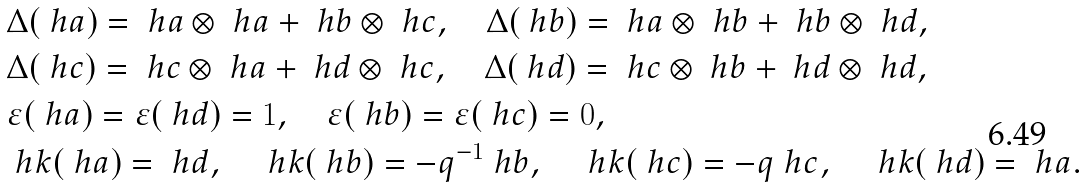<formula> <loc_0><loc_0><loc_500><loc_500>& \Delta ( \ h a ) = \ h a \otimes \ h a + \ h b \otimes \ h c , \quad \Delta ( \ h b ) = \ h a \otimes \ h b + \ h b \otimes \ h d , \\ & \Delta ( \ h c ) = \ h c \otimes \ h a + \ h d \otimes \ h c , \quad \Delta ( \ h d ) = \ h c \otimes \ h b + \ h d \otimes \ h d , \\ & \varepsilon ( \ h a ) = \varepsilon ( \ h d ) = 1 , \quad \varepsilon ( \ h b ) = \varepsilon ( \ h c ) = 0 , \\ & \ h k ( \ h a ) = \ h d , \quad \ h k ( \ h b ) = - q ^ { - 1 } \ h b , \quad \ h k ( \ h c ) = - q \ h c , \quad \ h k ( \ h d ) = \ h a .</formula> 